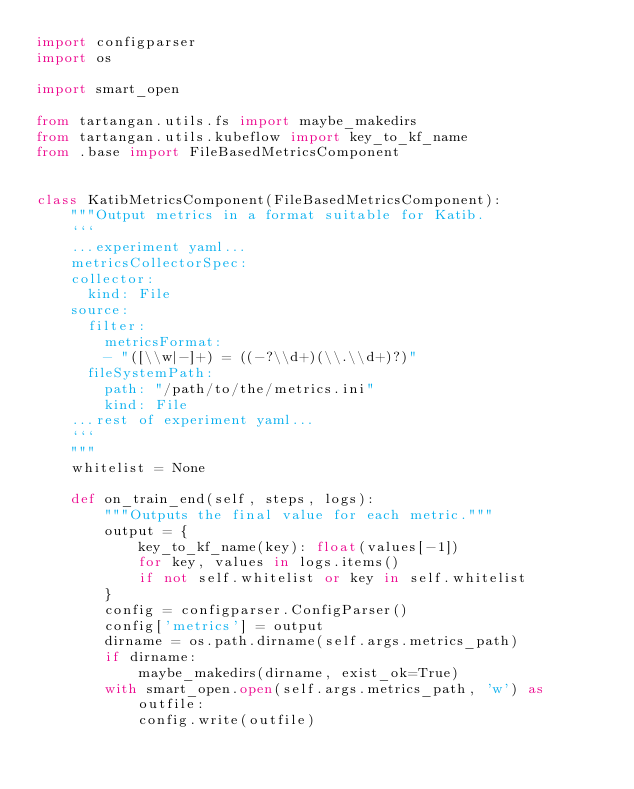<code> <loc_0><loc_0><loc_500><loc_500><_Python_>import configparser
import os

import smart_open

from tartangan.utils.fs import maybe_makedirs
from tartangan.utils.kubeflow import key_to_kf_name
from .base import FileBasedMetricsComponent


class KatibMetricsComponent(FileBasedMetricsComponent):
    """Output metrics in a format suitable for Katib.
    ```
    ...experiment yaml...
    metricsCollectorSpec:
    collector:
      kind: File
    source:
      filter:
        metricsFormat:
        - "([\\w|-]+) = ((-?\\d+)(\\.\\d+)?)"
      fileSystemPath:
        path: "/path/to/the/metrics.ini"
        kind: File
    ...rest of experiment yaml...
    ```
    """
    whitelist = None

    def on_train_end(self, steps, logs):
        """Outputs the final value for each metric."""
        output = {
            key_to_kf_name(key): float(values[-1])
            for key, values in logs.items()
            if not self.whitelist or key in self.whitelist
        }
        config = configparser.ConfigParser()
        config['metrics'] = output
        dirname = os.path.dirname(self.args.metrics_path)
        if dirname:
            maybe_makedirs(dirname, exist_ok=True)
        with smart_open.open(self.args.metrics_path, 'w') as outfile:
            config.write(outfile)
</code> 